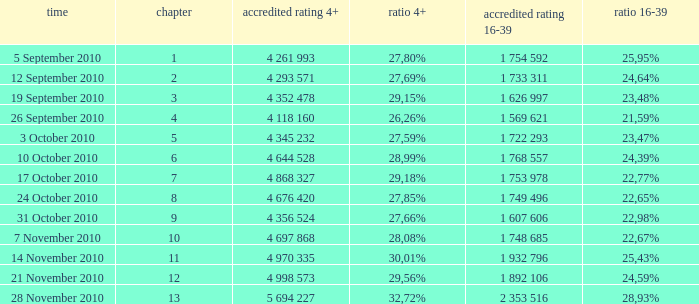What is the official rating 16-39 for the episode with  a 16-39 share of 22,77%? 1 753 978. 